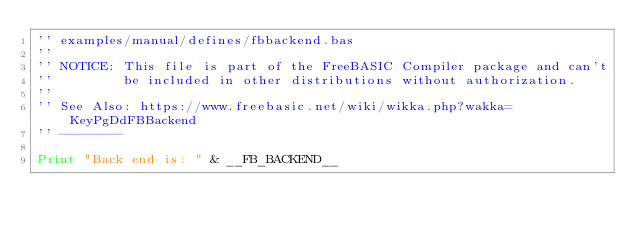Convert code to text. <code><loc_0><loc_0><loc_500><loc_500><_VisualBasic_>'' examples/manual/defines/fbbackend.bas
''
'' NOTICE: This file is part of the FreeBASIC Compiler package and can't
''         be included in other distributions without authorization.
''
'' See Also: https://www.freebasic.net/wiki/wikka.php?wakka=KeyPgDdFBBackend
'' --------

Print "Back end is: " & __FB_BACKEND__
	
</code> 